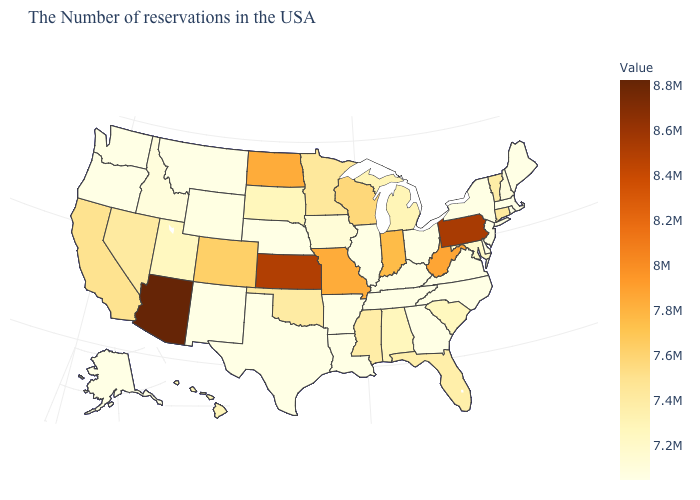Among the states that border Connecticut , which have the highest value?
Be succinct. New York. Does Wisconsin have a lower value than Wyoming?
Concise answer only. No. Does Michigan have the highest value in the USA?
Keep it brief. No. Among the states that border Virginia , does Kentucky have the highest value?
Short answer required. No. Does South Carolina have a higher value than Washington?
Give a very brief answer. Yes. 